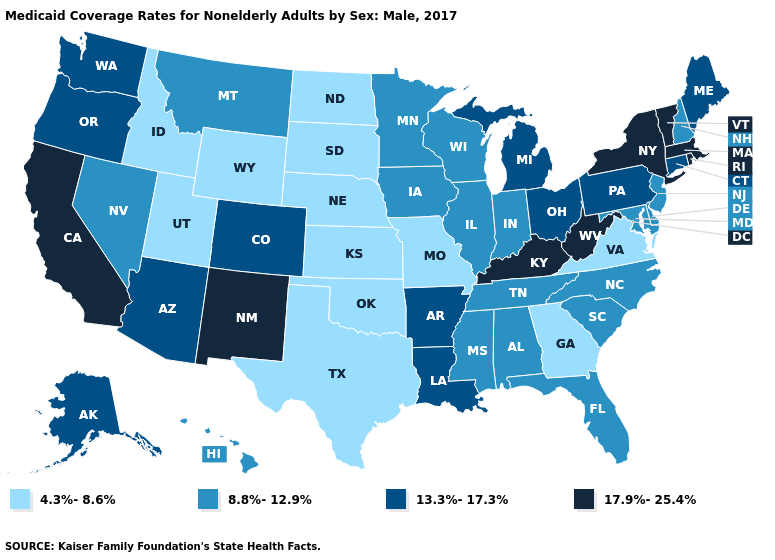Does the first symbol in the legend represent the smallest category?
Be succinct. Yes. What is the value of Vermont?
Quick response, please. 17.9%-25.4%. What is the lowest value in the USA?
Answer briefly. 4.3%-8.6%. Does Mississippi have a lower value than South Dakota?
Give a very brief answer. No. Among the states that border Oregon , does California have the highest value?
Keep it brief. Yes. Name the states that have a value in the range 4.3%-8.6%?
Write a very short answer. Georgia, Idaho, Kansas, Missouri, Nebraska, North Dakota, Oklahoma, South Dakota, Texas, Utah, Virginia, Wyoming. What is the value of Illinois?
Keep it brief. 8.8%-12.9%. Name the states that have a value in the range 4.3%-8.6%?
Quick response, please. Georgia, Idaho, Kansas, Missouri, Nebraska, North Dakota, Oklahoma, South Dakota, Texas, Utah, Virginia, Wyoming. Name the states that have a value in the range 8.8%-12.9%?
Quick response, please. Alabama, Delaware, Florida, Hawaii, Illinois, Indiana, Iowa, Maryland, Minnesota, Mississippi, Montana, Nevada, New Hampshire, New Jersey, North Carolina, South Carolina, Tennessee, Wisconsin. Does Wyoming have the lowest value in the West?
Be succinct. Yes. Name the states that have a value in the range 13.3%-17.3%?
Be succinct. Alaska, Arizona, Arkansas, Colorado, Connecticut, Louisiana, Maine, Michigan, Ohio, Oregon, Pennsylvania, Washington. What is the value of Virginia?
Quick response, please. 4.3%-8.6%. Which states have the highest value in the USA?
Keep it brief. California, Kentucky, Massachusetts, New Mexico, New York, Rhode Island, Vermont, West Virginia. Does the first symbol in the legend represent the smallest category?
Be succinct. Yes. What is the value of Kentucky?
Be succinct. 17.9%-25.4%. 